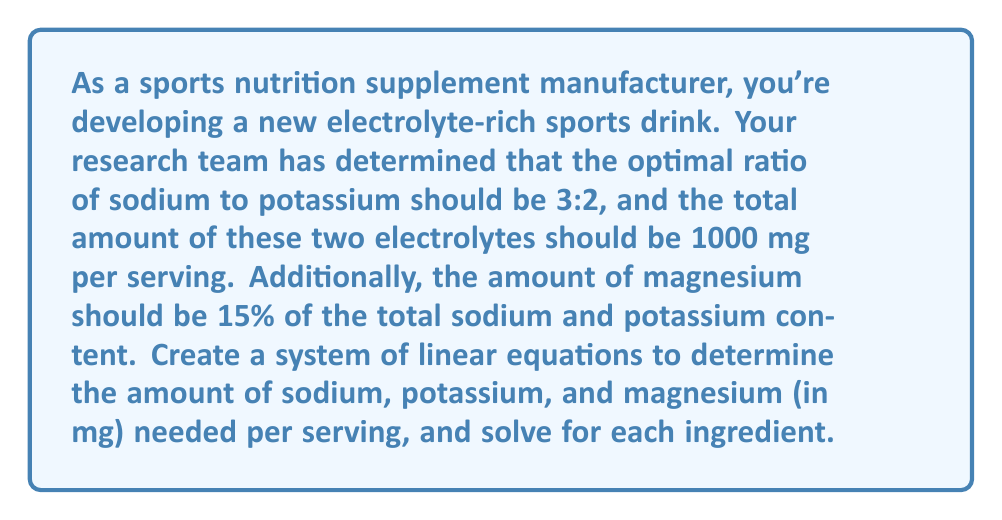Provide a solution to this math problem. Let's approach this problem step by step:

1) Let $x$ be the amount of sodium (in mg) and $y$ be the amount of potassium (in mg).

2) From the ratio of sodium to potassium (3:2), we can write our first equation:
   $$\frac{x}{y} = \frac{3}{2}$$ 
   This can be rewritten as: $$2x - 3y = 0$$

3) The total amount of sodium and potassium should be 1000 mg, giving us our second equation:
   $$x + y = 1000$$

4) Now we have a system of two equations with two unknowns:
   $$\begin{cases}
   2x - 3y = 0 \\
   x + y = 1000
   \end{cases}$$

5) We can solve this system by substitution. From the second equation:
   $$x = 1000 - y$$

6) Substituting this into the first equation:
   $$2(1000 - y) - 3y = 0$$
   $$2000 - 2y - 3y = 0$$
   $$2000 - 5y = 0$$
   $$5y = 2000$$
   $$y = 400$$

7) Now we can find $x$:
   $$x = 1000 - y = 1000 - 400 = 600$$

8) To find the amount of magnesium, we calculate 15% of the total sodium and potassium:
   $$\text{Magnesium} = 0.15(x + y) = 0.15(600 + 400) = 0.15(1000) = 150$$

Therefore, the optimal amounts per serving are:
- Sodium: 600 mg
- Potassium: 400 mg
- Magnesium: 150 mg
Answer: Sodium: 600 mg
Potassium: 400 mg
Magnesium: 150 mg 